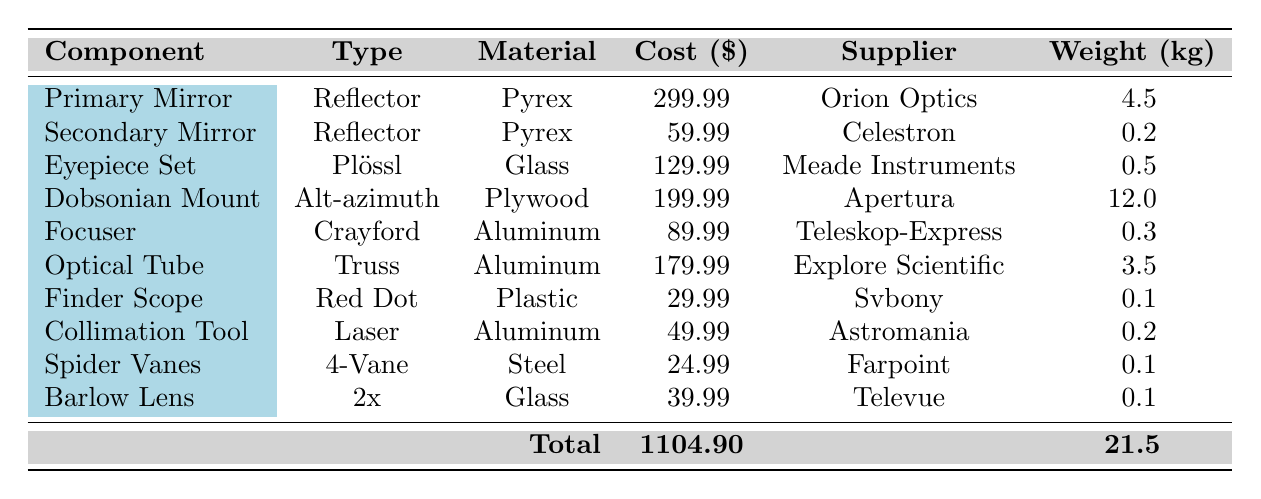What is the cost of the Primary Mirror component? The table directly lists the cost of each component. For the Primary Mirror, it specifies the cost as 299.99.
Answer: 299.99 Which component has the highest weight? By comparing the weights of all the components listed in the table, the Dobsonian Mount is the only one with a weight of 12.0 kg, which is the highest among all.
Answer: Dobsonian Mount What is the total cost of all the components listed in the table? The total cost is shown in the table at the bottom, and it sums up to 1104.90 from the individual component costs.
Answer: 1104.90 Is the Secondary Mirror made of Aluminum? The table states that the Secondary Mirror is made of Pyrex, not Aluminum, which confirms that the claim is false.
Answer: No What is the average cost of the components made of Glass? The components made of Glass are the Eyepiece Set and the Barlow Lens, with costs of 129.99 and 39.99 respectively. Their average is calculated as (129.99 + 39.99) / 2 = 84.99.
Answer: 84.99 How many components are supplied by Orion Optics? Referring to the table, only the Primary Mirror is supplied by Orion Optics, thus there is just one component from this supplier.
Answer: 1 Which type of telescope component has the least cost? The cheapest component listed in the table is the Finder Scope, which costs 29.99, making it the least expensive.
Answer: Finder Scope Is the Eyepiece Set heavier than the Barlow Lens? The table indicates the weight of the Eyepiece Set is 0.5 kg, while the Barlow Lens weighs 0.1 kg. Since 0.5 kg is greater than 0.1 kg, this statement is true.
Answer: Yes Calculate the total weight of the components made of Aluminum. The components made from Aluminum are the Focuser and Optical Tube, weighing 0.3 kg and 3.5 kg respectively. Their total weight is calculated as 0.3 + 3.5 = 3.8 kg.
Answer: 3.8 kg 